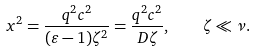Convert formula to latex. <formula><loc_0><loc_0><loc_500><loc_500>x ^ { 2 } = \frac { q ^ { 2 } c ^ { 2 } } { ( \varepsilon - 1 ) \zeta ^ { 2 } } = \frac { q ^ { 2 } c ^ { 2 } } { D \zeta } , \quad \zeta \ll \nu .</formula> 